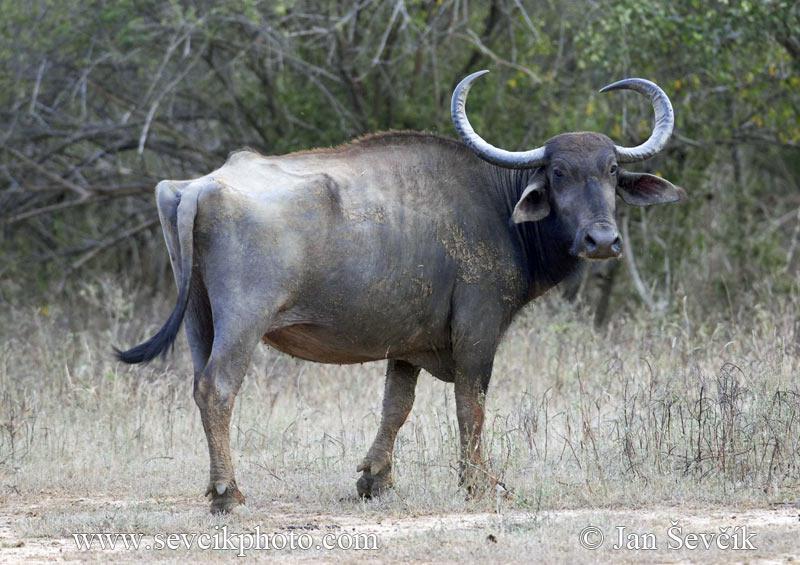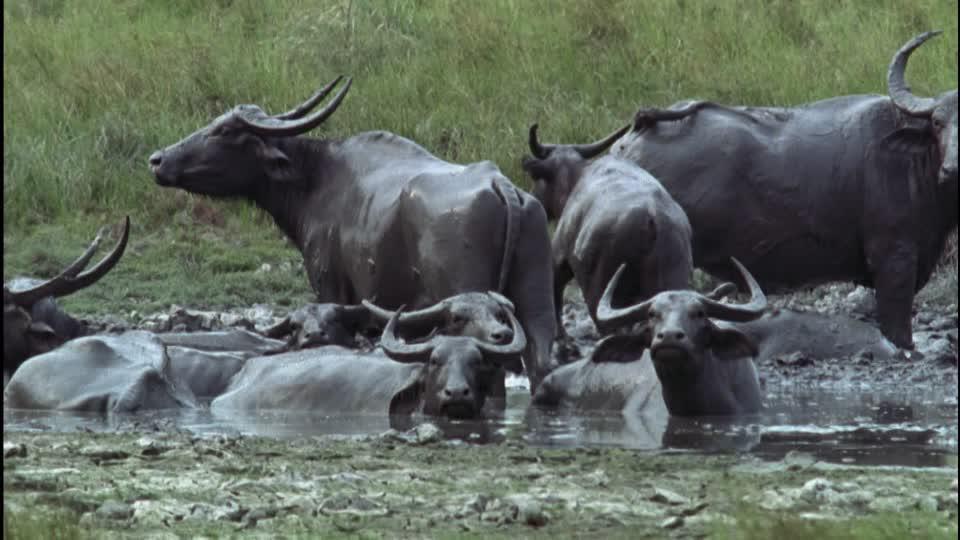The first image is the image on the left, the second image is the image on the right. Evaluate the accuracy of this statement regarding the images: "Left image shows water buffalo upright in water.". Is it true? Answer yes or no. No. 